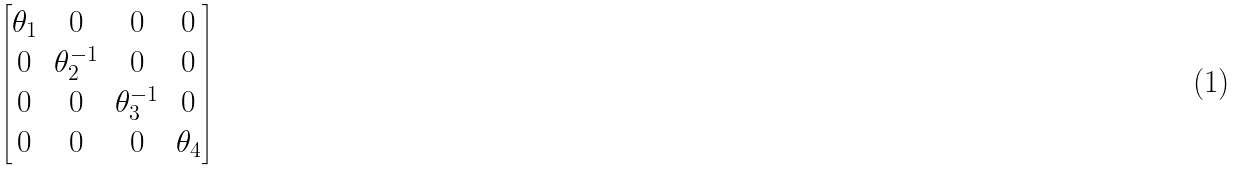<formula> <loc_0><loc_0><loc_500><loc_500>\begin{bmatrix} \theta _ { 1 } & 0 & 0 & 0 \\ 0 & \theta _ { 2 } ^ { - 1 } & 0 & 0 \\ 0 & 0 & \theta _ { 3 } ^ { - 1 } & 0 \\ 0 & 0 & 0 & \theta _ { 4 } \end{bmatrix}</formula> 